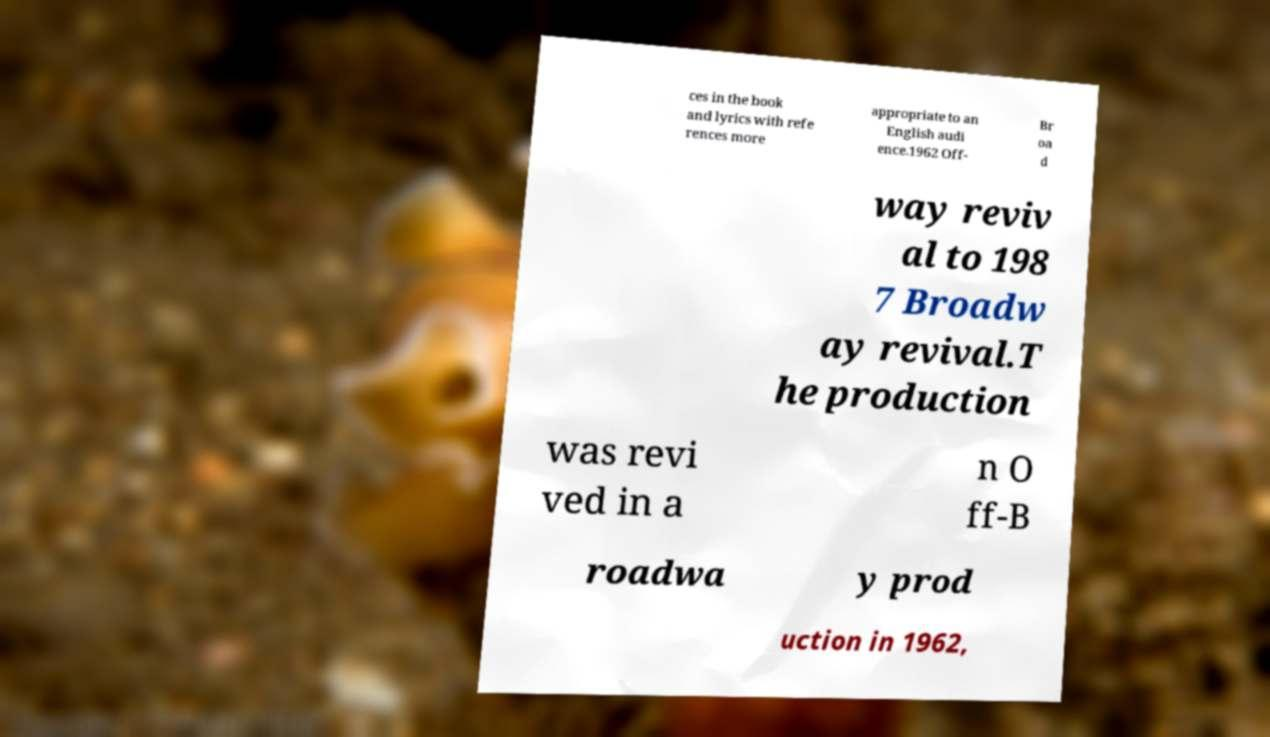Can you read and provide the text displayed in the image?This photo seems to have some interesting text. Can you extract and type it out for me? ces in the book and lyrics with refe rences more appropriate to an English audi ence.1962 Off- Br oa d way reviv al to 198 7 Broadw ay revival.T he production was revi ved in a n O ff-B roadwa y prod uction in 1962, 